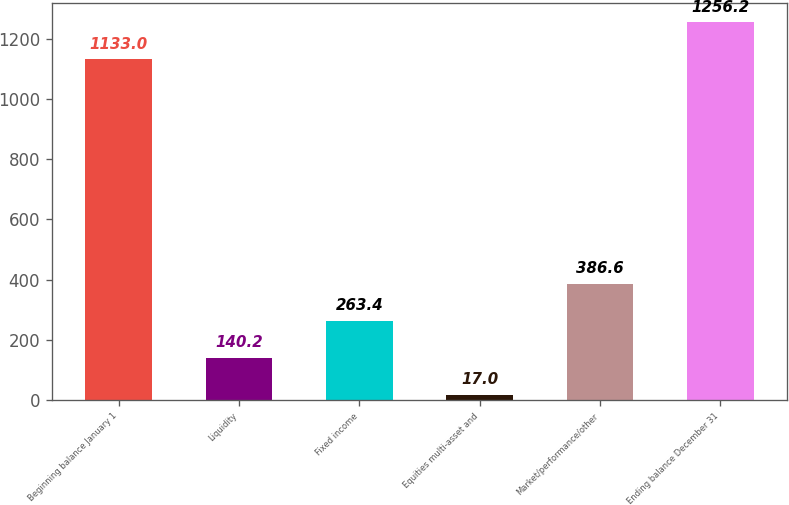Convert chart to OTSL. <chart><loc_0><loc_0><loc_500><loc_500><bar_chart><fcel>Beginning balance January 1<fcel>Liquidity<fcel>Fixed income<fcel>Equities multi-asset and<fcel>Market/performance/other<fcel>Ending balance December 31<nl><fcel>1133<fcel>140.2<fcel>263.4<fcel>17<fcel>386.6<fcel>1256.2<nl></chart> 